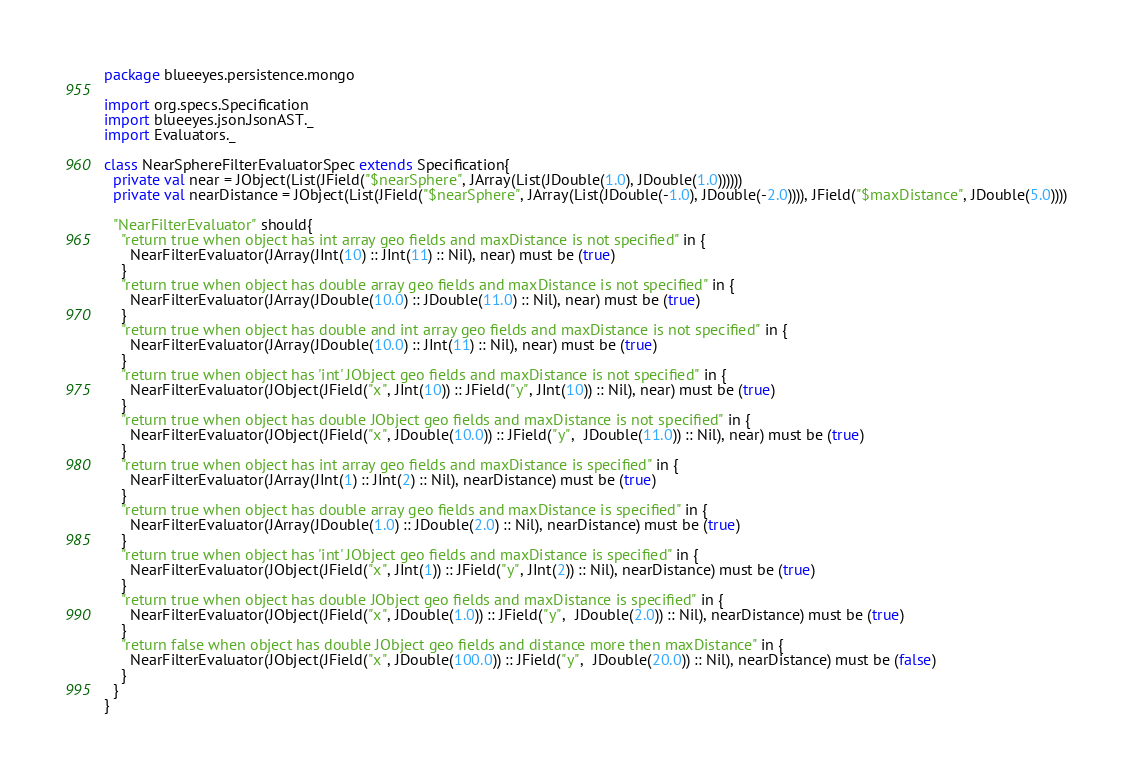Convert code to text. <code><loc_0><loc_0><loc_500><loc_500><_Scala_>package blueeyes.persistence.mongo

import org.specs.Specification
import blueeyes.json.JsonAST._
import Evaluators._

class NearSphereFilterEvaluatorSpec extends Specification{
  private val near = JObject(List(JField("$nearSphere", JArray(List(JDouble(1.0), JDouble(1.0))))))
  private val nearDistance = JObject(List(JField("$nearSphere", JArray(List(JDouble(-1.0), JDouble(-2.0)))), JField("$maxDistance", JDouble(5.0))))

  "NearFilterEvaluator" should{
    "return true when object has int array geo fields and maxDistance is not specified" in {
      NearFilterEvaluator(JArray(JInt(10) :: JInt(11) :: Nil), near) must be (true)
    }
    "return true when object has double array geo fields and maxDistance is not specified" in {
      NearFilterEvaluator(JArray(JDouble(10.0) :: JDouble(11.0) :: Nil), near) must be (true)
    }
    "return true when object has double and int array geo fields and maxDistance is not specified" in {
      NearFilterEvaluator(JArray(JDouble(10.0) :: JInt(11) :: Nil), near) must be (true)
    }
    "return true when object has 'int' JObject geo fields and maxDistance is not specified" in {
      NearFilterEvaluator(JObject(JField("x", JInt(10)) :: JField("y", JInt(10)) :: Nil), near) must be (true)
    }
    "return true when object has double JObject geo fields and maxDistance is not specified" in {
      NearFilterEvaluator(JObject(JField("x", JDouble(10.0)) :: JField("y",  JDouble(11.0)) :: Nil), near) must be (true)
    }
    "return true when object has int array geo fields and maxDistance is specified" in {
      NearFilterEvaluator(JArray(JInt(1) :: JInt(2) :: Nil), nearDistance) must be (true)
    }
    "return true when object has double array geo fields and maxDistance is specified" in {
      NearFilterEvaluator(JArray(JDouble(1.0) :: JDouble(2.0) :: Nil), nearDistance) must be (true)
    }
    "return true when object has 'int' JObject geo fields and maxDistance is specified" in {
      NearFilterEvaluator(JObject(JField("x", JInt(1)) :: JField("y", JInt(2)) :: Nil), nearDistance) must be (true)
    }
    "return true when object has double JObject geo fields and maxDistance is specified" in {
      NearFilterEvaluator(JObject(JField("x", JDouble(1.0)) :: JField("y",  JDouble(2.0)) :: Nil), nearDistance) must be (true)
    }
    "return false when object has double JObject geo fields and distance more then maxDistance" in {
      NearFilterEvaluator(JObject(JField("x", JDouble(100.0)) :: JField("y",  JDouble(20.0)) :: Nil), nearDistance) must be (false)
    }
  }
}</code> 